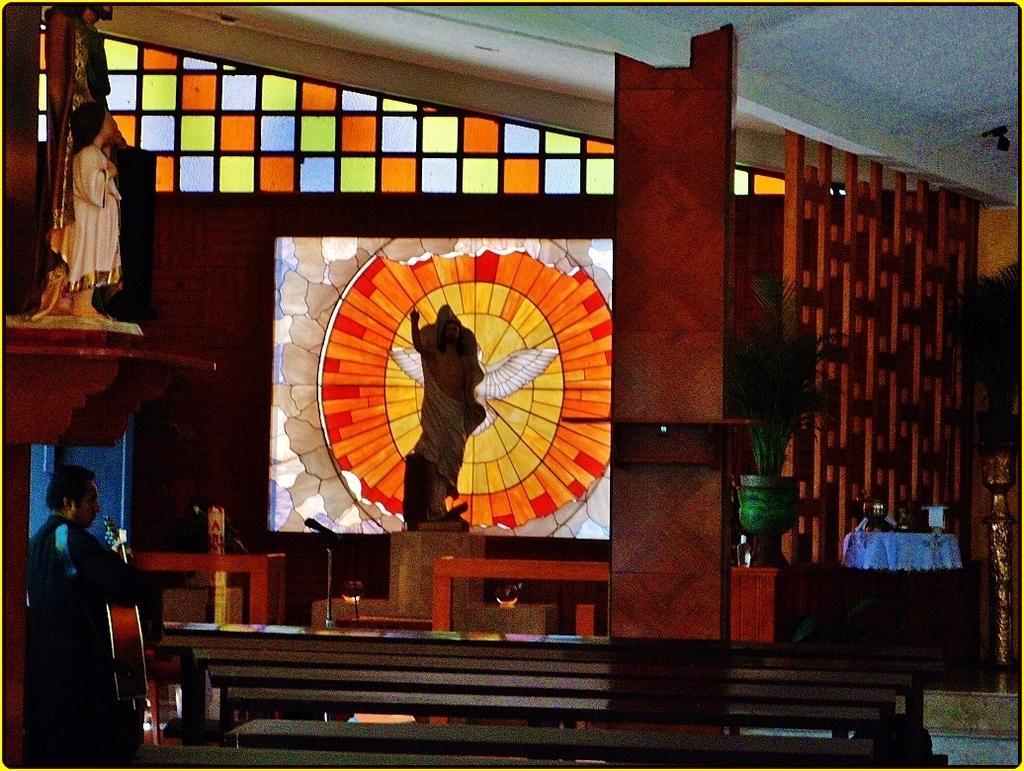Describe this image in one or two sentences. In the image we can see a man standing, wearing clothes and holding a guitar in the hands. Here we can see the sculptures, pillars and plant pot. We can even see stairs and glass windows of different colors. 